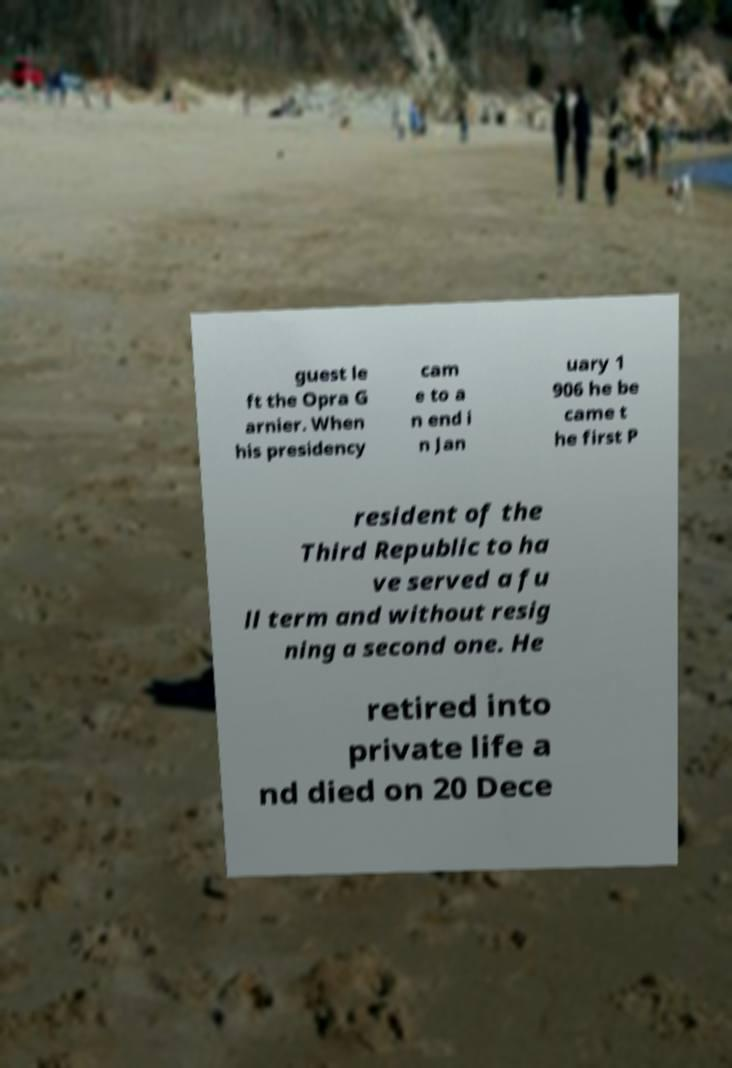I need the written content from this picture converted into text. Can you do that? guest le ft the Opra G arnier. When his presidency cam e to a n end i n Jan uary 1 906 he be came t he first P resident of the Third Republic to ha ve served a fu ll term and without resig ning a second one. He retired into private life a nd died on 20 Dece 